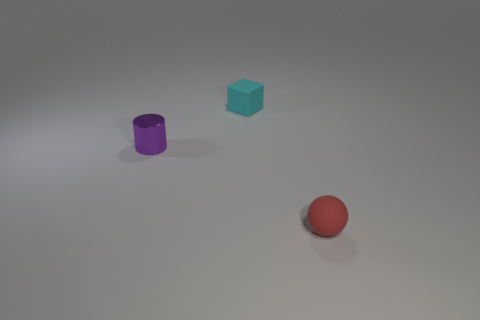Add 2 small rubber balls. How many objects exist? 5 Subtract all cubes. How many objects are left? 2 Add 3 rubber things. How many rubber things are left? 5 Add 3 spheres. How many spheres exist? 4 Subtract 1 cyan cubes. How many objects are left? 2 Subtract all green cylinders. Subtract all cyan matte blocks. How many objects are left? 2 